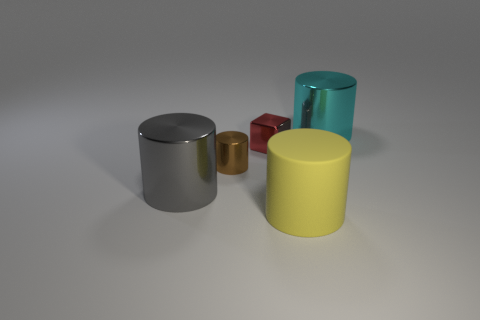Subtract 2 cylinders. How many cylinders are left? 2 Add 3 small brown shiny cylinders. How many objects exist? 8 Subtract all red cylinders. Subtract all purple balls. How many cylinders are left? 4 Subtract all cylinders. How many objects are left? 1 Add 3 tiny things. How many tiny things exist? 5 Subtract 0 green cylinders. How many objects are left? 5 Subtract all big things. Subtract all small purple things. How many objects are left? 2 Add 5 yellow matte objects. How many yellow matte objects are left? 6 